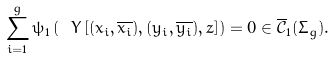<formula> <loc_0><loc_0><loc_500><loc_500>\sum _ { i = 1 } ^ { g } \psi _ { 1 } \left ( \ Y \left [ ( x _ { i } , \overline { x _ { i } } ) , ( y _ { i } , \overline { y _ { i } } ) , z \right ] \right ) = 0 \in \overline { \mathcal { C } } _ { 1 } ( \Sigma _ { g } ) .</formula> 